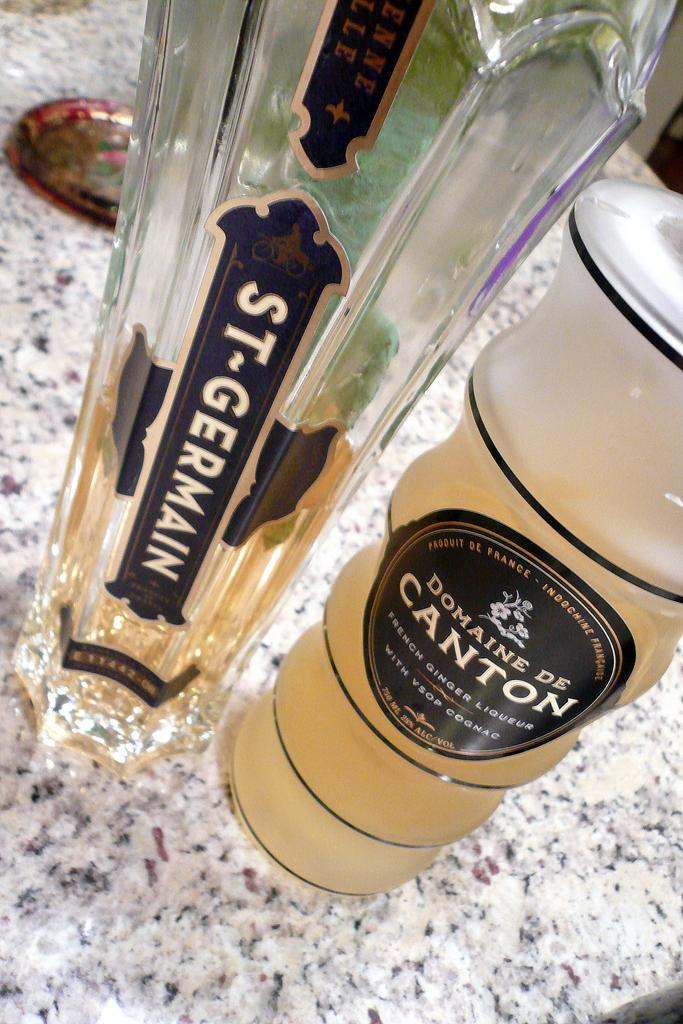<image>
Provide a brief description of the given image. A bottle of St. Germain sits next to a bottle of Domaine de Canton. 